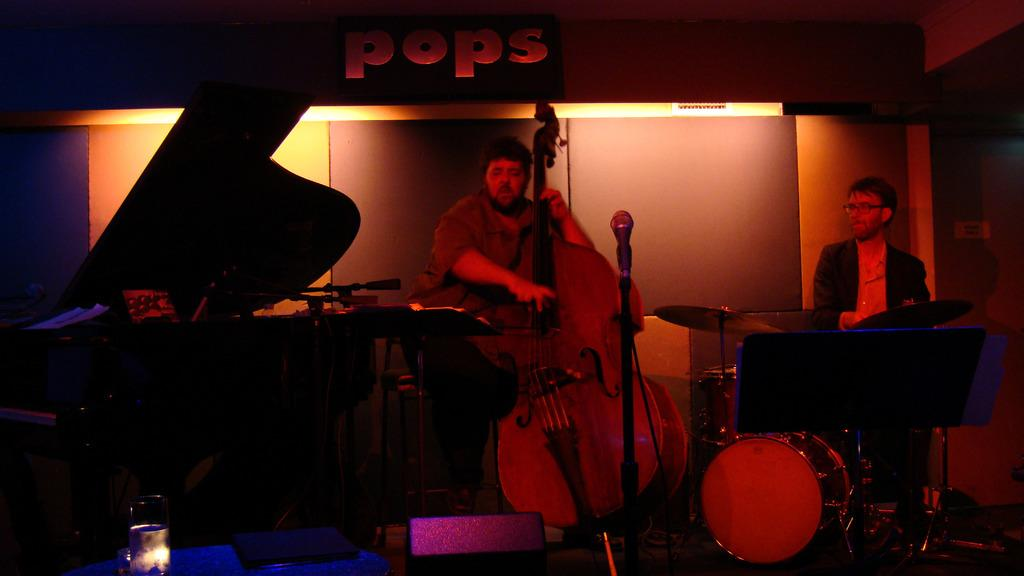What is the man in the image doing? The man is playing a guitar in the image. Are there any other musical instruments present in the image? Yes, there are musical instruments in the image. What is the man doing with the musical instruments? The man is playing the musical instruments. What device is present for amplifying the man's voice? There is a mic with a holder in the image. What type of bomb can be seen in the image? There is no bomb present in the image; it features a man playing musical instruments. What is the title of the song the man is playing in the image? The image does not provide any information about the title of the song being played. 